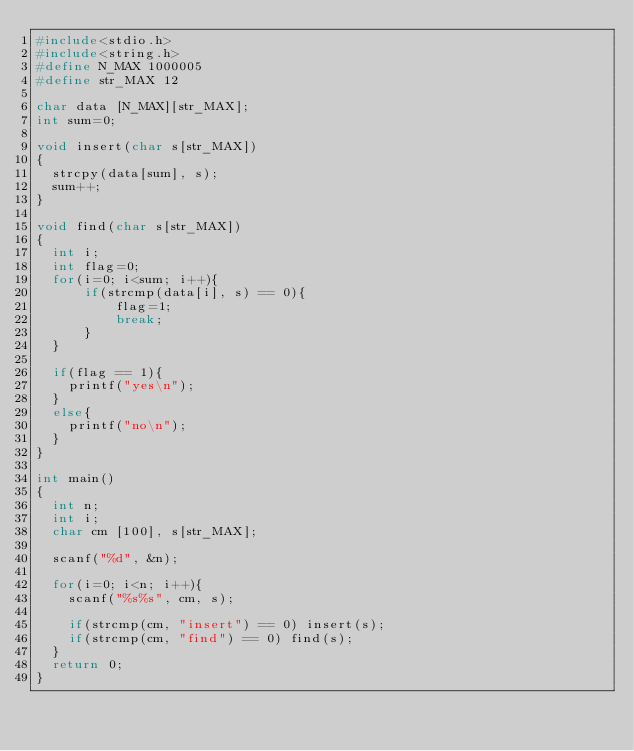<code> <loc_0><loc_0><loc_500><loc_500><_C_>#include<stdio.h>
#include<string.h>
#define N_MAX 1000005
#define str_MAX 12

char data [N_MAX][str_MAX];
int sum=0;

void insert(char s[str_MAX])
{	
	strcpy(data[sum], s);
	sum++;
}

void find(char s[str_MAX])
{
	int i;
	int flag=0;
	for(i=0; i<sum; i++){
			if(strcmp(data[i], s) == 0){
					flag=1;
					break;
			}
	}

	if(flag == 1){
		printf("yes\n");
	}
	else{
		printf("no\n");
	}
}

int main()
{
	int n;
	int i;
	char cm [100], s[str_MAX];

	scanf("%d", &n);

	for(i=0; i<n; i++){
		scanf("%s%s", cm, s);

		if(strcmp(cm, "insert") == 0) insert(s);
		if(strcmp(cm, "find") == 0) find(s);
	}
	return 0;
}</code> 